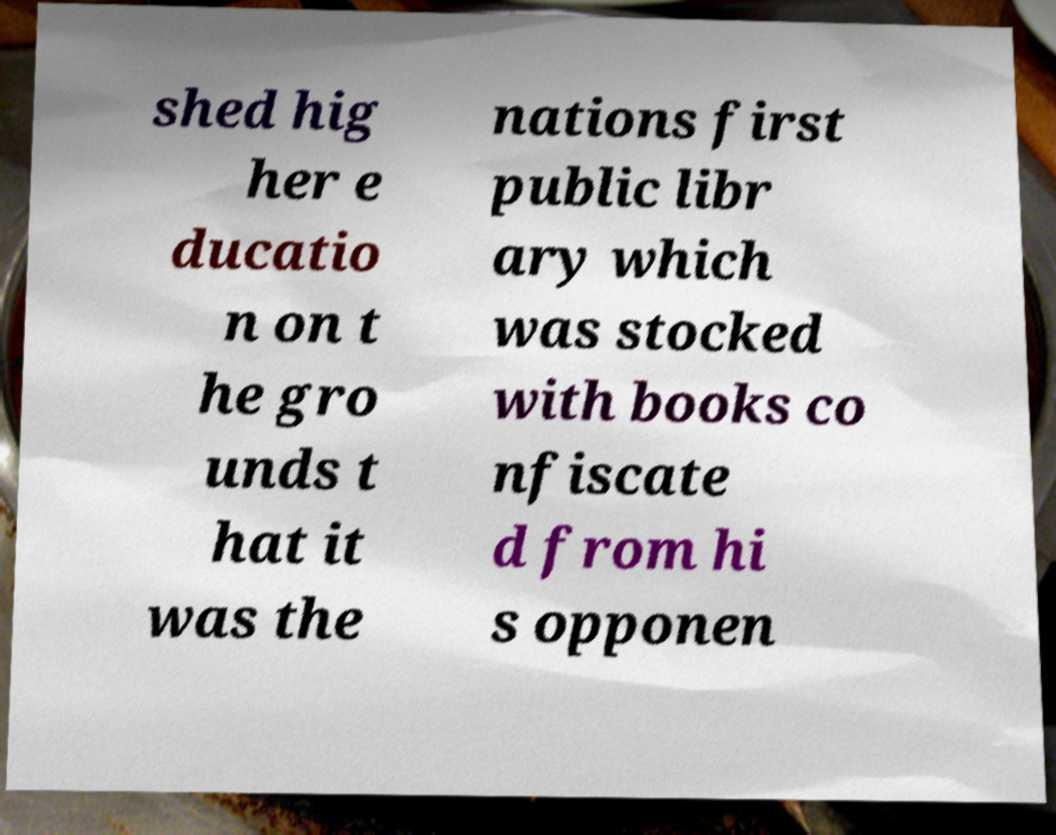Please read and relay the text visible in this image. What does it say? shed hig her e ducatio n on t he gro unds t hat it was the nations first public libr ary which was stocked with books co nfiscate d from hi s opponen 